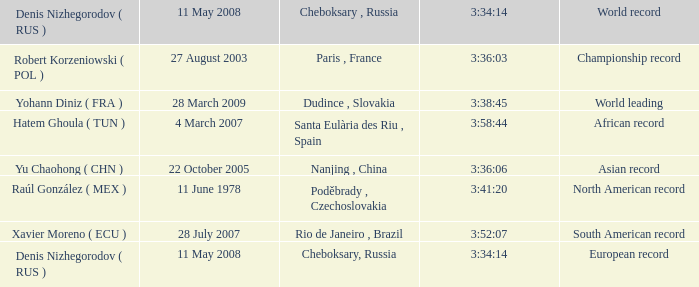When 3:41:20 is  3:34:14 what is cheboksary , russia? Poděbrady , Czechoslovakia. 